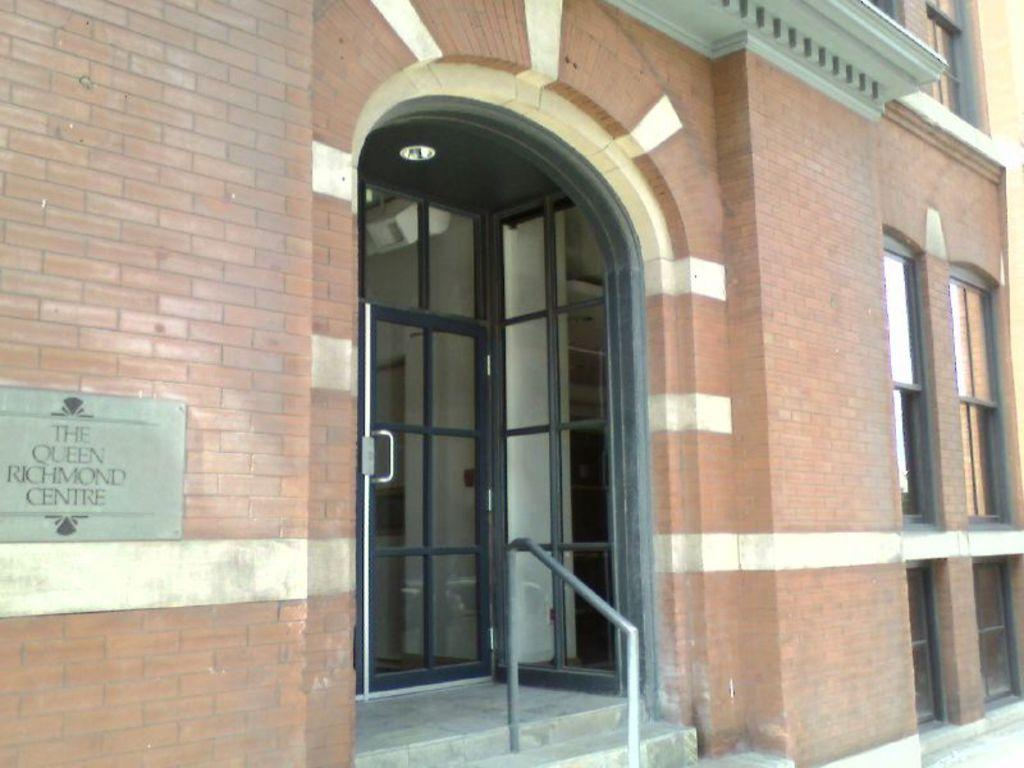What type of structure is present in the image? There is a building in the image. What features can be observed on the building? The building has glass doors and windows. Are there any architectural elements in front of the building? Yes, there are stairs with a metal rod in front of the building. Can the name of the building be identified in the image? Yes, the name of the building is engraved on it. What type of thread is used to hold the insurance policy in the image? There is no thread or insurance policy present in the image. 